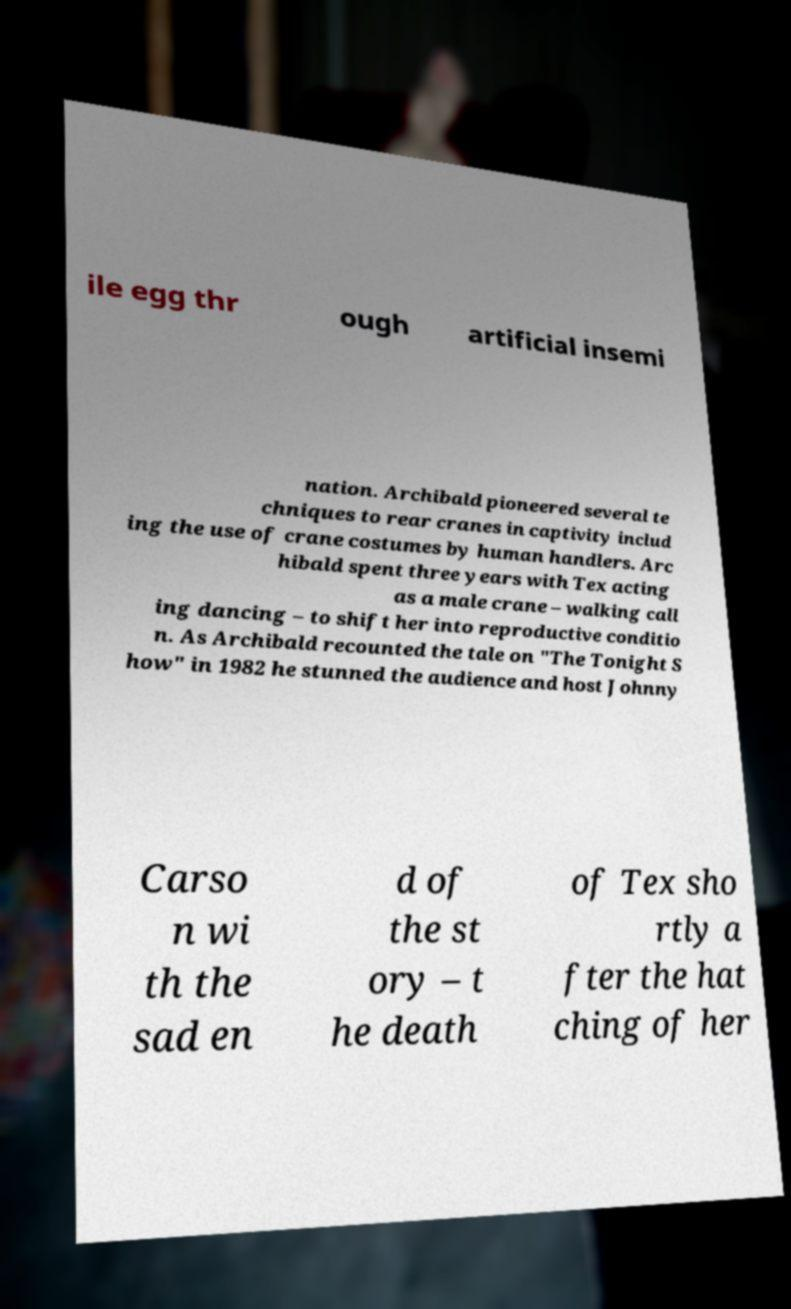There's text embedded in this image that I need extracted. Can you transcribe it verbatim? ile egg thr ough artificial insemi nation. Archibald pioneered several te chniques to rear cranes in captivity includ ing the use of crane costumes by human handlers. Arc hibald spent three years with Tex acting as a male crane – walking call ing dancing – to shift her into reproductive conditio n. As Archibald recounted the tale on "The Tonight S how" in 1982 he stunned the audience and host Johnny Carso n wi th the sad en d of the st ory – t he death of Tex sho rtly a fter the hat ching of her 